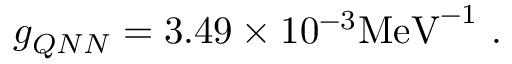<formula> <loc_0><loc_0><loc_500><loc_500>g _ { Q N N } = 3 . 4 9 \times 1 0 ^ { - 3 } M e V ^ { - 1 } .</formula> 